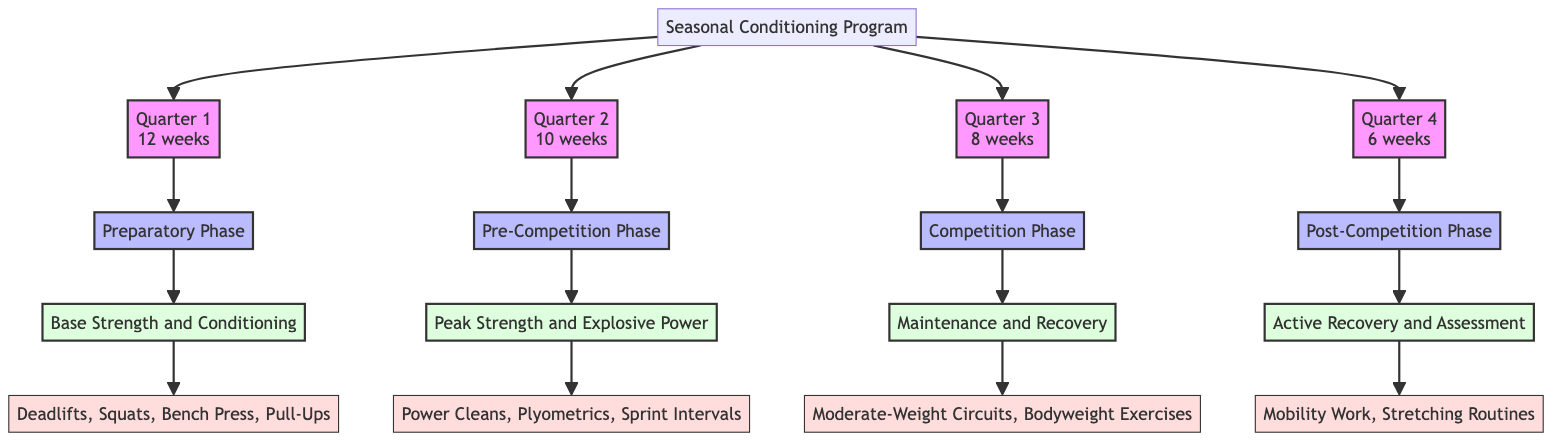What is the duration of Quarter 1? In the diagram, Quarter 1 is labeled with the duration of "12 weeks". This information directly follows the node representing Quarter 1, linking duration to the specific quarter.
Answer: 12 weeks What is the focus of the Competition Phase? The Competition Phase is linked to the focus labeled as "Maintenance and Recovery". By following the connections from the Competition Phase node, one finds the specific focus noted directly beneath it.
Answer: Maintenance and Recovery How many primary exercises are listed in the Pre-Competition Phase? The Pre-Competition Phase includes the primary exercises: "Power Cleans, Plyometrics, Sprint Intervals". Counting these listed exercises reveals there are three primary exercises in this phase.
Answer: 3 What is the adjustment stated for Quarter 4? The adjustment for Quarter 4 is mentioned as "Relaxed Volume, Relaxed Intensity". This information can be traced back to the Post-Competition Phase node, where the specific adjustments are elaborated.
Answer: Relaxed Volume, Relaxed Intensity Which type of cardio is emphasized during the Preparatory Phase? The Preparatory Phase emphasizes two types of cardio: "Long-Distance Runs" and "Swimming". Referring to the focus of the Preparatory Phase, we find the related cardio activities directly below it.
Answer: Long-Distance Runs and Swimming List the primary exercises for Quarter 3. Quarter 3 focuses on the Competition Phase, which includes the primary exercises: "Moderate-Weight Circuits, Bodyweight Exercises". By locating the node for Quarter 3 and reviewing the subsequent linked exercises, the complete list can be retrieved.
Answer: Moderate-Weight Circuits, Bodyweight Exercises What is the phase of Quarter 2? Quarter 2 is defined as the "Pre-Competition Phase". This is labeled directly from the Quarter 2 node, making it straightforward to identify the corresponding phase.
Answer: Pre-Competition Phase What is the cardio approach in the Post-Competition Phase? In the Post-Competition Phase, the cardio approach includes "Yoga" and "Swimming". By identifying the relevant cardio node linked to the Post-Competition Phase, these activities can be clearly articulated.
Answer: Yoga and Swimming What adjustments are made during the Pre-Competition Phase? The adjustments for the Pre-Competition Phase state to "Decrease Volume, Increase Intensity". This can be seen directly beneath the node representing the Pre-Competition Phase.
Answer: Decrease Volume, Increase Intensity 